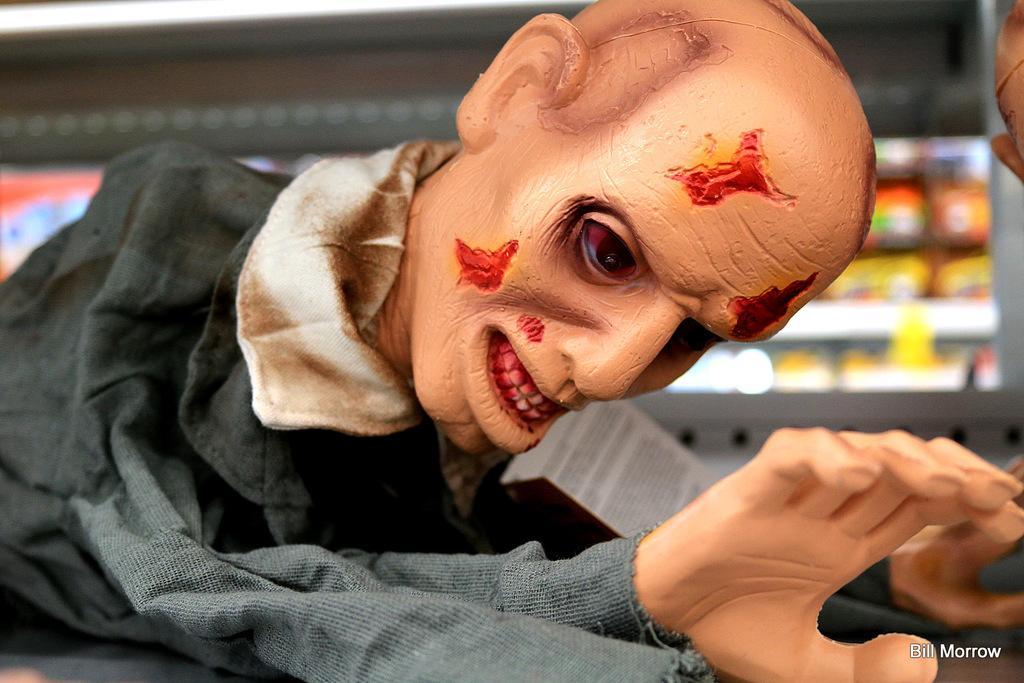In one or two sentences, can you explain what this image depicts? In the picture I can see a sculpture of a person. The background of the image is blurred. On the bottom right side of the image I can see a watermark. 